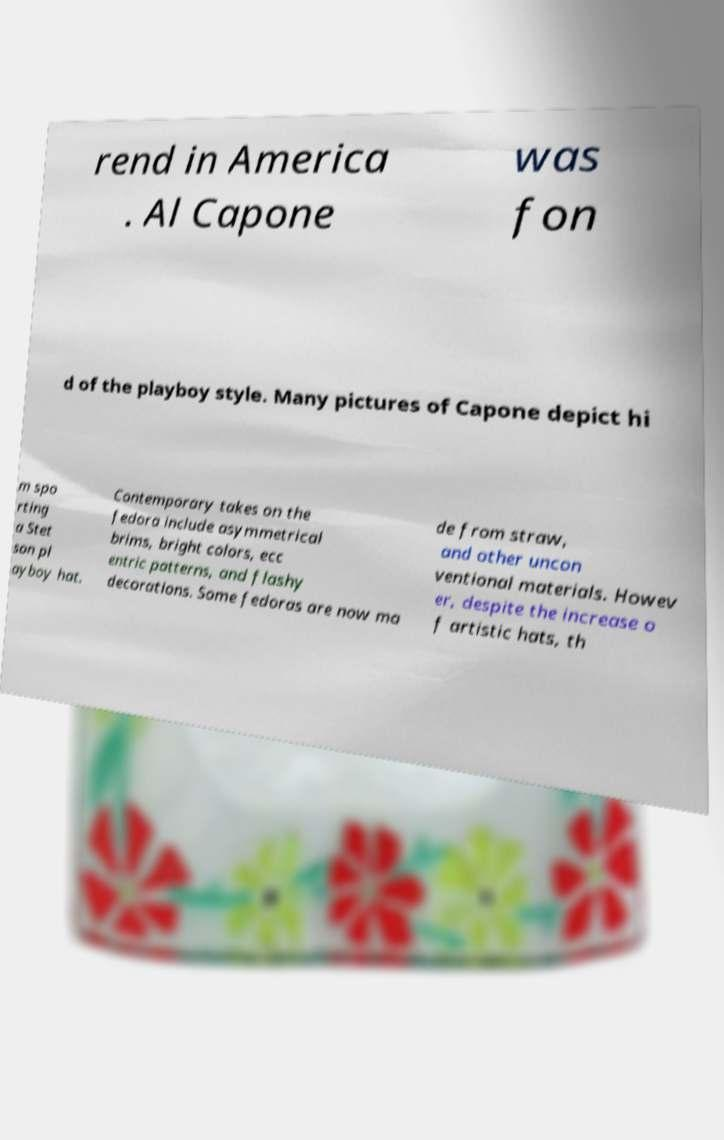For documentation purposes, I need the text within this image transcribed. Could you provide that? rend in America . Al Capone was fon d of the playboy style. Many pictures of Capone depict hi m spo rting a Stet son pl ayboy hat. Contemporary takes on the fedora include asymmetrical brims, bright colors, ecc entric patterns, and flashy decorations. Some fedoras are now ma de from straw, and other uncon ventional materials. Howev er, despite the increase o f artistic hats, th 